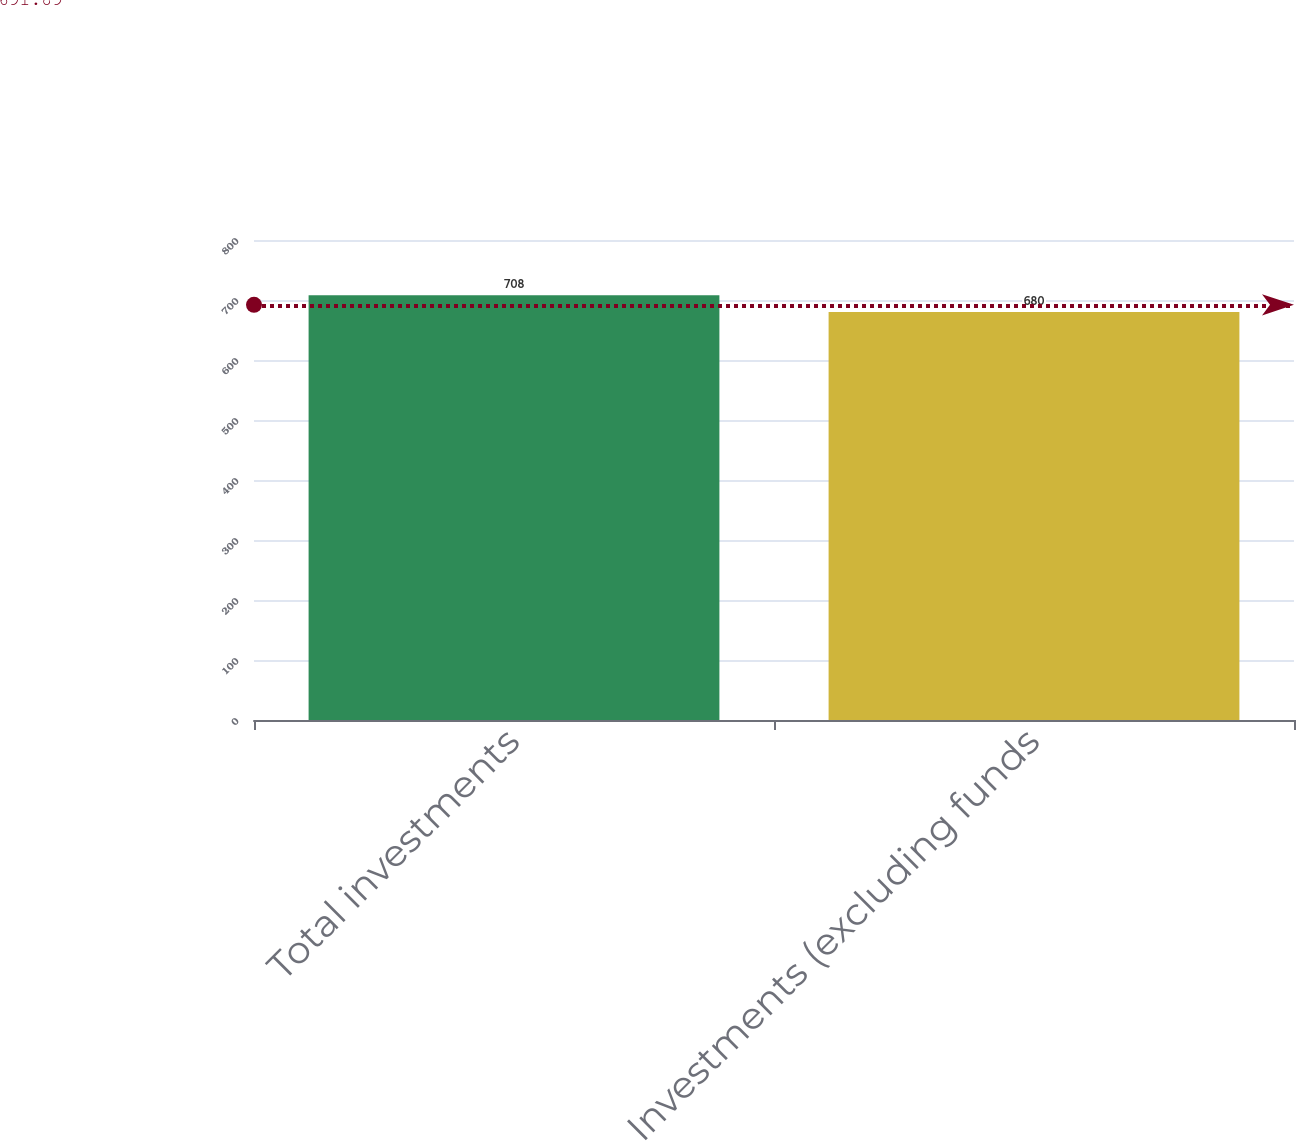Convert chart to OTSL. <chart><loc_0><loc_0><loc_500><loc_500><bar_chart><fcel>Total investments<fcel>Investments (excluding funds<nl><fcel>708<fcel>680<nl></chart> 